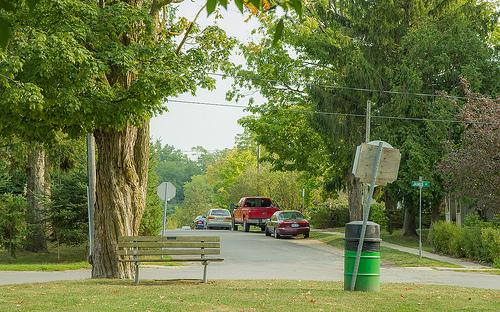Describe what the street looks like in this image. The street in the image is a T-shaped concrete road for automobile traffic with cars parked on the side and a stop sign. Choose one object from the image and describe it in detail. A green and black trash can can be found in the image, partially covered with a black garbage bag, located on the grass near the corner of the street. Analyze the emotion of the scene portrayed in the image. The scene portrays a calm and peaceful atmosphere, depicting everyday life on a quiet street. What kind of establishment might be present in this area based on the objects provided in the image? Given the presence of a park with a wooden bench, large trees, and a grassy area, this area might be a residential neighborhood. What color is the car parked in front of the red truck? The car parked in front of the red truck is green. What kind of sign can you see behind the trash can in the image? There is a street name sign and a stop sign behind the trash can. Where is the wooden bench located in the image, and what is it near? The wooden bench is located in the park near a large tree and on the edge of the grass. Explain the relationship between the trash can and the sign behind it. The trash can is located in front of the sign which is placed for public information, while the trash can is for the public to dispose of their waste. Both objects are part of the street infrastructure. Mention one prominent feature in this image related to nature. A large patch of grassy area is a prominent feature related to nature in this image. Count the total number of vehicles parked on the side of the road in the image. There are 6 vehicles parked on the side of the road. Regarding coordinates X:407 Y:174, what object can be found, and what text is on it? Street sign, street name text Find any anomalies or unusual aspects in the image. Purple tree (X:430 Y:216) appears unnatural. Which objects interact with the green and black trash can (X:345 Y:220)? Stop sign and street sign Determine if there is anything unusual about the tree located at X:430 Y:216. The tree is purple, which is unusual. What type of road can be found at coordinates X:4 Y:223? Concrete road for automobile traffic You might want to pay special attention to the white cat sitting on the wooden bench in the park area, as it seems to be resting peacefully. The instruction mentions a non-existent white cat on the wooden bench, and the way it is phrased evokes engagement and curiosity, leading the reader to believe the presence of a cat in the image. Can you locate the blue bicycle near the wooden bench? The bicycle should be locked to the bench. There is no mention of a blue bicycle in the image information provided, but the instruction is detailed and asks a question, which can mislead readers into thinking there is a bicycle in the image. Rate the quality of the image from 1 to 10. 8, the image is clear and well composed Analyze the interactions between objects in the image. Bench facing tree, trash can in front of stop sign, red truck parked by other cars, street sign at corner What color is the trash can in the image? Green and black Identify any text in the image. Street name on the green street sign (X:410 Y:173) Ground the referential expressions in the image, as per their coordinates. "Wooden bench in the park" (X:118 Y:232), "back of a stop sign" (X:158 Y:179), "large tree" (X:98 Y:56) Observe the vibrant sunflower garden next to the row of cars on the side of the road. They should be blooming beautifully. No, it's not mentioned in the image. I would like to direct your attention towards a stop sign painted with graffiti near the green trash can, showcasing some local street art. The instruction paints a picture of a stop sign with graffiti near the trash can, which is not mentioned in the image information. The mention of local street art can pique the reader's interest, leading them to search for it within the image. Notice how the little boy flies a blue kite in the grassy area, surrounded by large trees on this cloudy day. There is no little boy or a blue kite mentioned in the image information, but the instruction provides a detailed and concise narrative, leading the reader to believe there is a boy flying a kite in the grassy area. Identify the objects in the image and their positions. Trash can (X:345 Y:220), street sign (X:410 Y:173), bench (X:118 Y:232), tree (X:98 Y:56), cars (X:193 Y:191), stop sign (X:158 Y:179), grass (X:45 Y:275), trees (X:345 Y:21), red truck (X:233 Y:191), T-shaped street (X:65 Y:243) Detect the attributes of the trash can and the red truck. Trash can: green and black, (X:345 Y:220); Red truck: parked in row, (X:233 Y:191) What is the sentiment of the image depicting a t-shaped street (X:65 Y:243)? Neutral Segment the objects in the image semantically. Four segments: Vehicles, Trees and Vegetation, Road and Street features, Street furniture Identify the sentiment of the image with a bench in the grass (X:97 Y:195)? Pleasant or relaxing Which vehicle is parked in front of the orange truck: red car, purple car, or light tan SUV? Light tan SUV Isn't it strange that there is a large pink sculpture of an elephant near the large tree, something we don't typically see in a park? This instruction asks a question about a large pink elephant sculpture that doesn't exist in the image. The uniqueness of the object described and the interrogative format can lead readers to search for such an interesting and odd object in the image. Describe the overall sentiment of the image. Neutral, as it depicts a typical outdoor street scene. Describe the scene depicted in the image, including objects and interactions. An outdoor street scene with a wooden bench facing a tree, a green and black trash can in front of a stop sign, cars parked along the road, and a green street sign on the corner. 